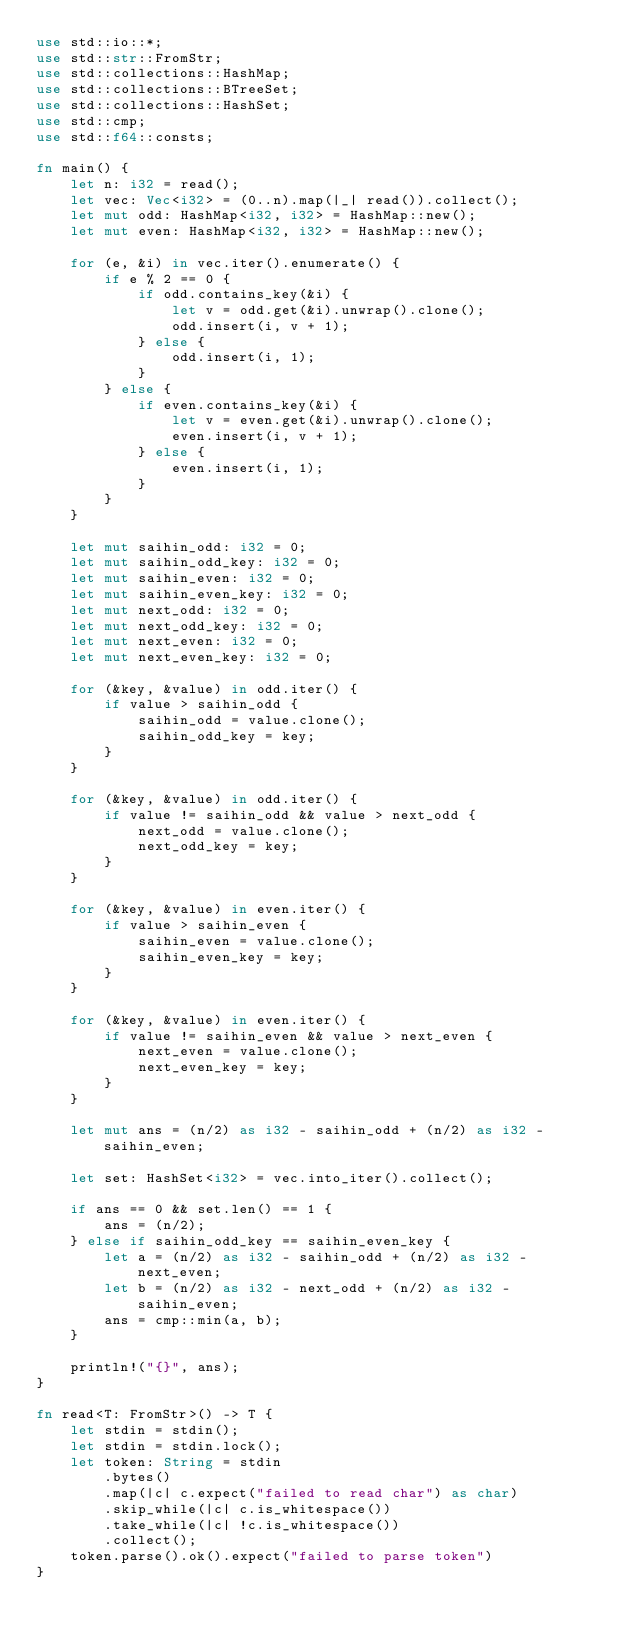Convert code to text. <code><loc_0><loc_0><loc_500><loc_500><_Rust_>use std::io::*;
use std::str::FromStr;
use std::collections::HashMap;
use std::collections::BTreeSet;
use std::collections::HashSet;
use std::cmp;
use std::f64::consts;

fn main() {
    let n: i32 = read();
    let vec: Vec<i32> = (0..n).map(|_| read()).collect();
    let mut odd: HashMap<i32, i32> = HashMap::new();
    let mut even: HashMap<i32, i32> = HashMap::new();

    for (e, &i) in vec.iter().enumerate() {
        if e % 2 == 0 {
            if odd.contains_key(&i) {
                let v = odd.get(&i).unwrap().clone();
                odd.insert(i, v + 1);
            } else {
                odd.insert(i, 1);
            }
        } else {
            if even.contains_key(&i) {
                let v = even.get(&i).unwrap().clone();
                even.insert(i, v + 1);
            } else {
                even.insert(i, 1);
            }
        }
    }

    let mut saihin_odd: i32 = 0;
    let mut saihin_odd_key: i32 = 0;
    let mut saihin_even: i32 = 0;
    let mut saihin_even_key: i32 = 0;
    let mut next_odd: i32 = 0;
    let mut next_odd_key: i32 = 0;
    let mut next_even: i32 = 0;
    let mut next_even_key: i32 = 0;

    for (&key, &value) in odd.iter() {
        if value > saihin_odd {
            saihin_odd = value.clone();
            saihin_odd_key = key;
        }
    }

    for (&key, &value) in odd.iter() {
        if value != saihin_odd && value > next_odd {
            next_odd = value.clone();
            next_odd_key = key;
        }
    }

    for (&key, &value) in even.iter() {
        if value > saihin_even {
            saihin_even = value.clone();
            saihin_even_key = key;
        }
    }

    for (&key, &value) in even.iter() {
        if value != saihin_even && value > next_even {
            next_even = value.clone();
            next_even_key = key;
        }
    }

    let mut ans = (n/2) as i32 - saihin_odd + (n/2) as i32 - saihin_even;

    let set: HashSet<i32> = vec.into_iter().collect();

    if ans == 0 && set.len() == 1 {
        ans = (n/2);
    } else if saihin_odd_key == saihin_even_key {
        let a = (n/2) as i32 - saihin_odd + (n/2) as i32 - next_even;
        let b = (n/2) as i32 - next_odd + (n/2) as i32 - saihin_even;
        ans = cmp::min(a, b);
    }
    
    println!("{}", ans);
}

fn read<T: FromStr>() -> T {
    let stdin = stdin();
    let stdin = stdin.lock();
    let token: String = stdin
        .bytes()
        .map(|c| c.expect("failed to read char") as char)
        .skip_while(|c| c.is_whitespace())
        .take_while(|c| !c.is_whitespace())
        .collect();
    token.parse().ok().expect("failed to parse token")
}
</code> 